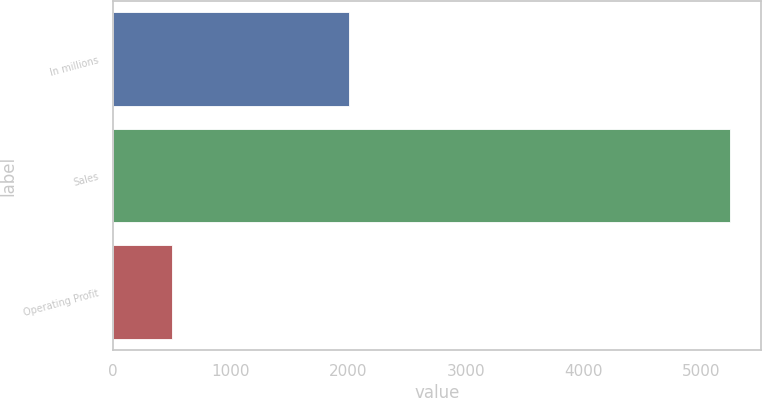Convert chart. <chart><loc_0><loc_0><loc_500><loc_500><bar_chart><fcel>In millions<fcel>Sales<fcel>Operating Profit<nl><fcel>2007<fcel>5245<fcel>501<nl></chart> 